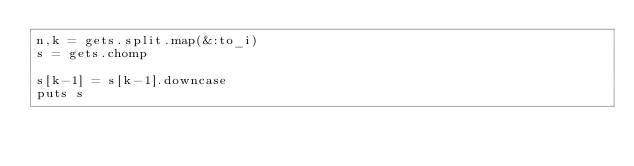<code> <loc_0><loc_0><loc_500><loc_500><_Ruby_>n,k = gets.split.map(&:to_i)
s = gets.chomp

s[k-1] = s[k-1].downcase
puts s
</code> 